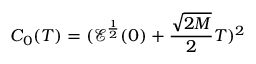<formula> <loc_0><loc_0><loc_500><loc_500>C _ { 0 } ( T ) = ( \mathcal { E } ^ { \frac { 1 } { 2 } } ( 0 ) + \frac { \sqrt { 2 M } } { 2 } T ) ^ { 2 }</formula> 